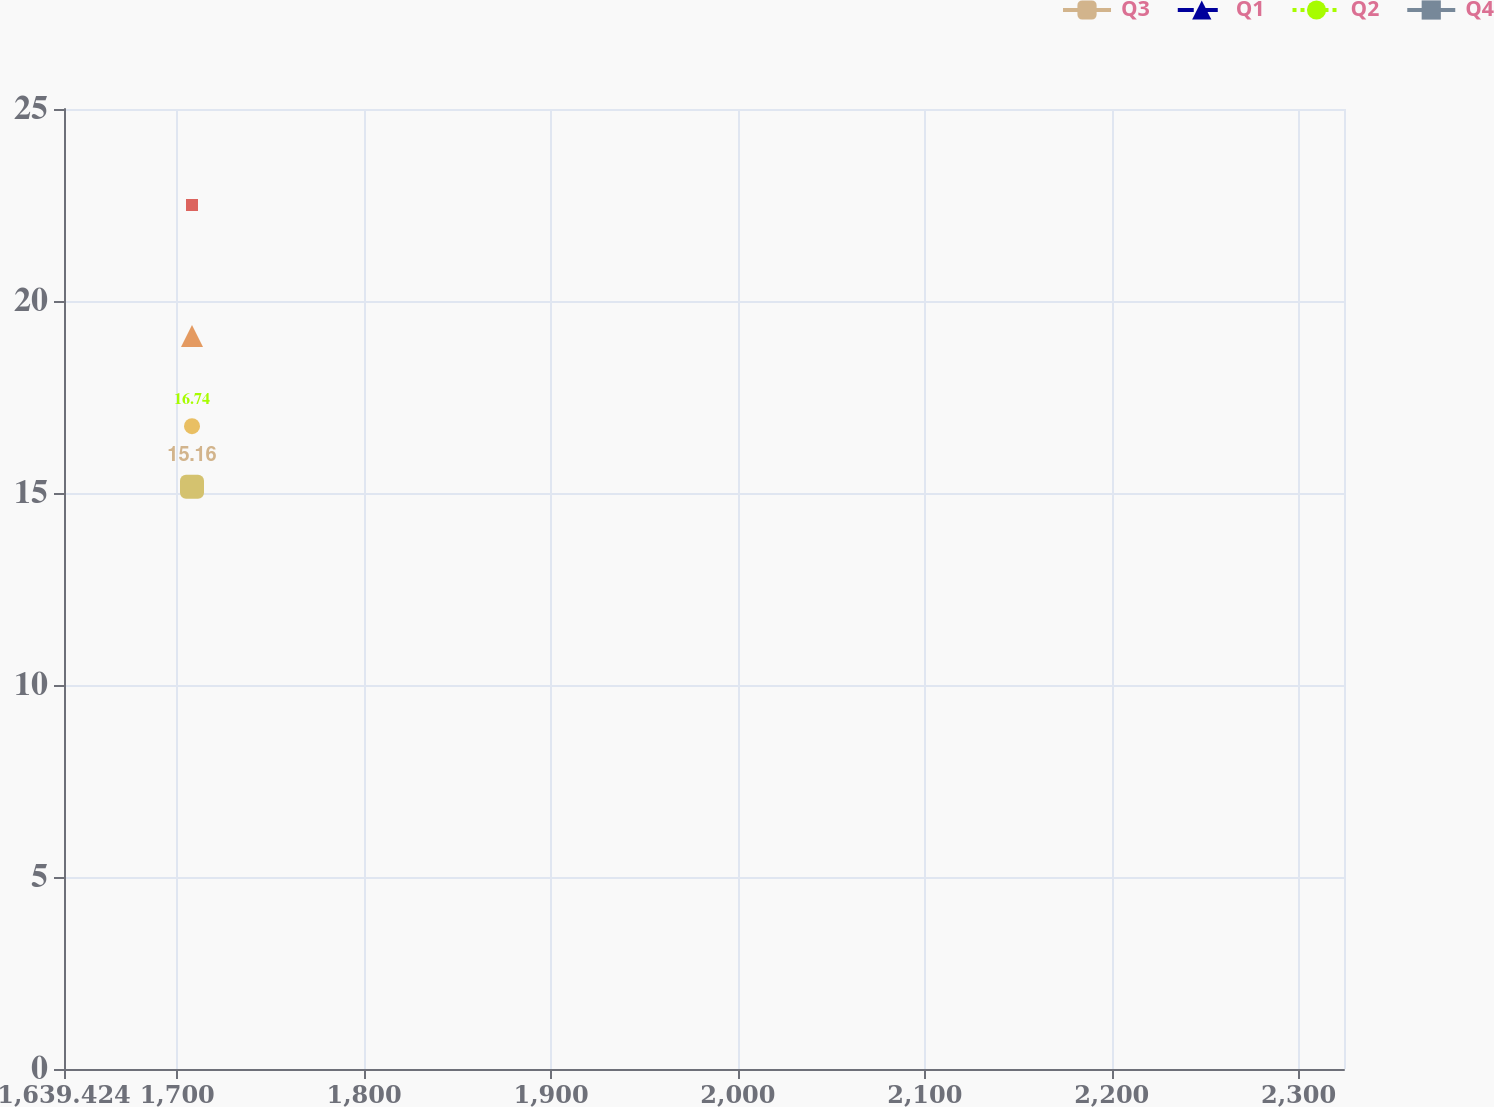Convert chart. <chart><loc_0><loc_0><loc_500><loc_500><line_chart><ecel><fcel>Q3<fcel>Q1<fcel>Q2<fcel>Q4<nl><fcel>1707.91<fcel>15.16<fcel>19.09<fcel>16.74<fcel>22.5<nl><fcel>2326.23<fcel>9.56<fcel>8.58<fcel>8.69<fcel>14.03<nl><fcel>2392.77<fcel>23.92<fcel>18.11<fcel>15.3<fcel>12.74<nl></chart> 